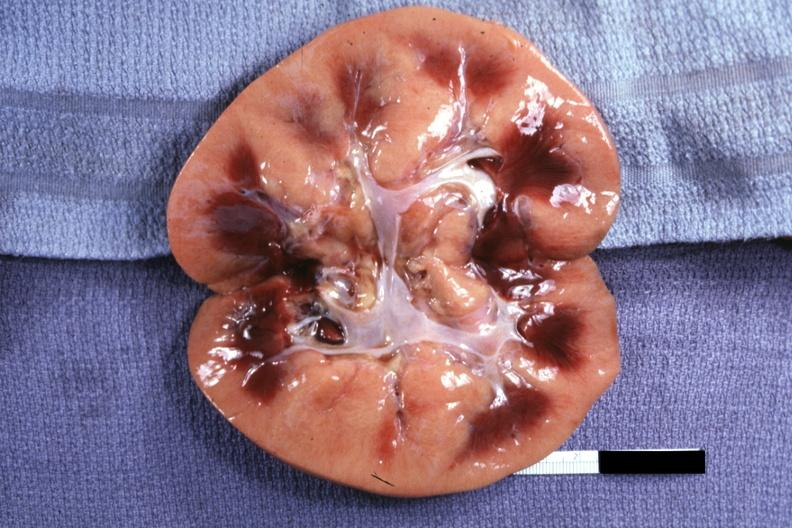s acute inflammation present?
Answer the question using a single word or phrase. No 